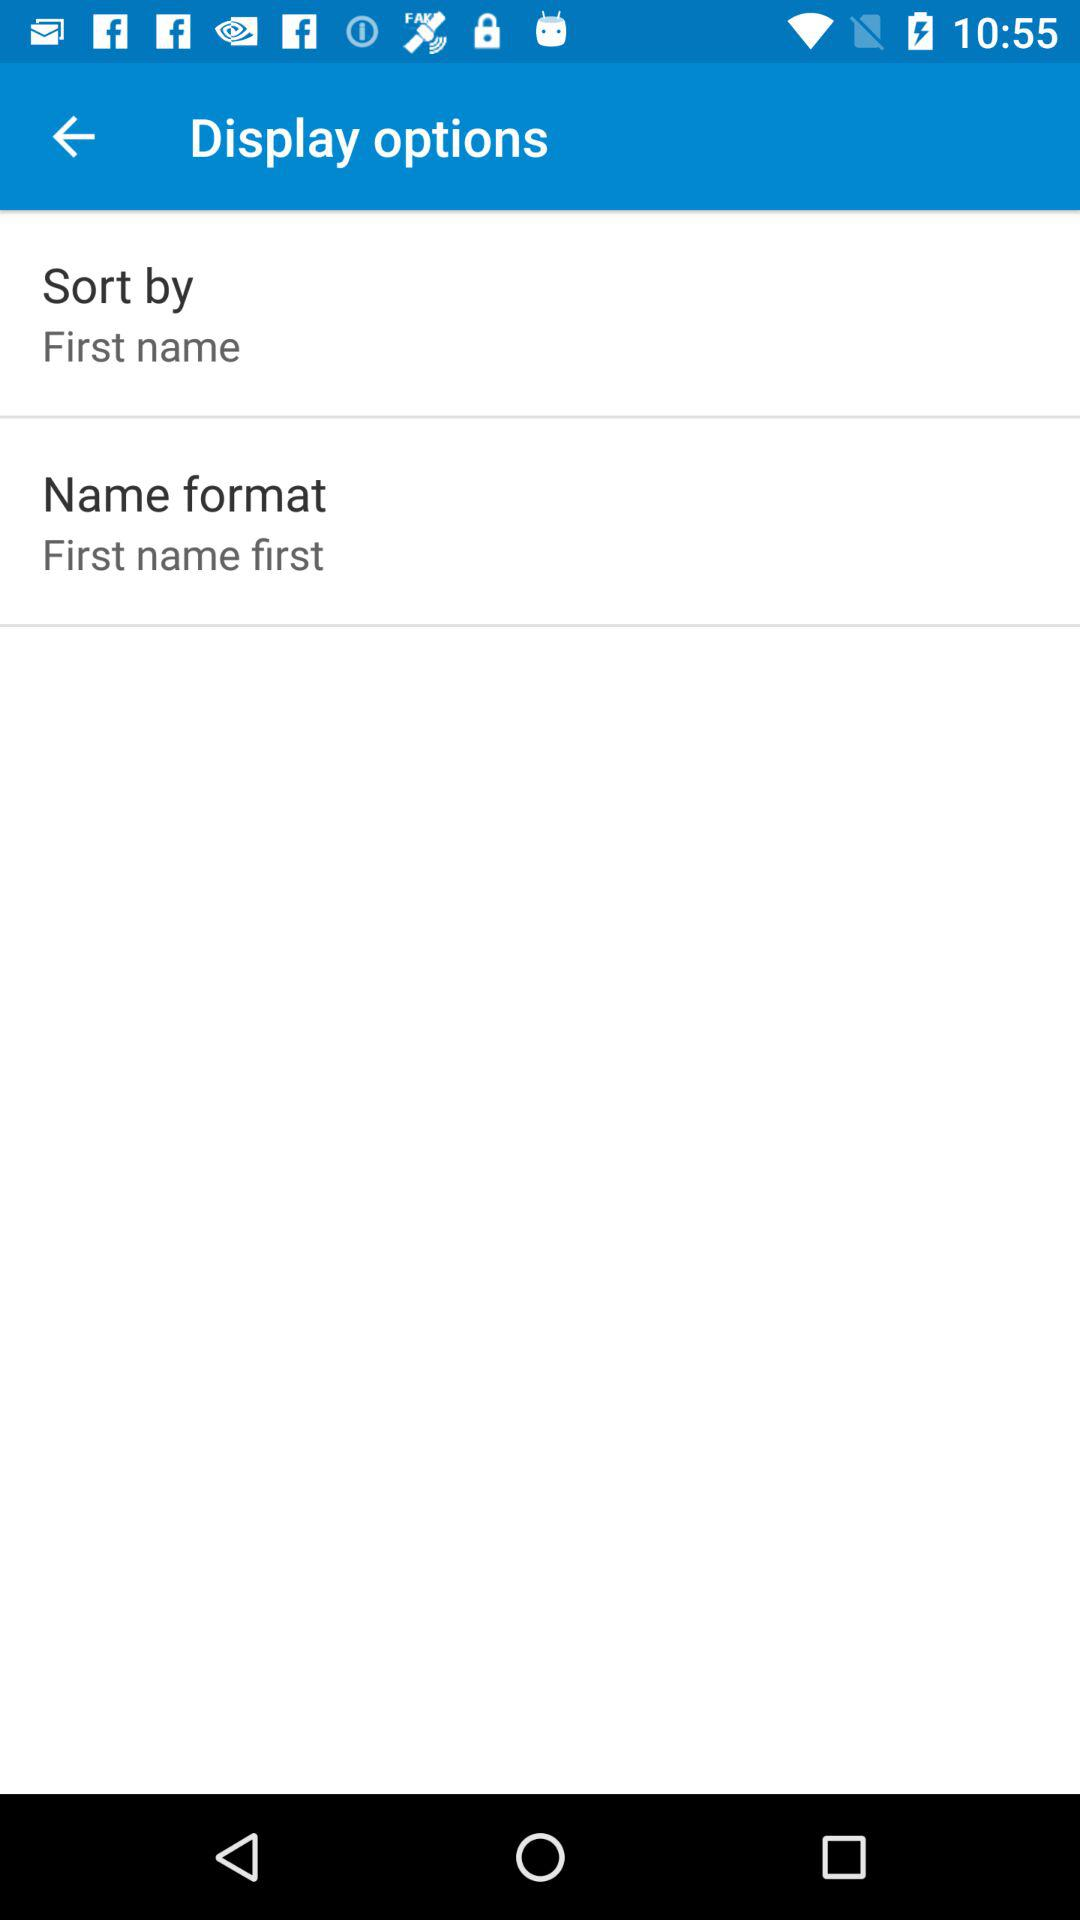What is the setting for "Name format"? The setting for "Name format" is "First name first". 